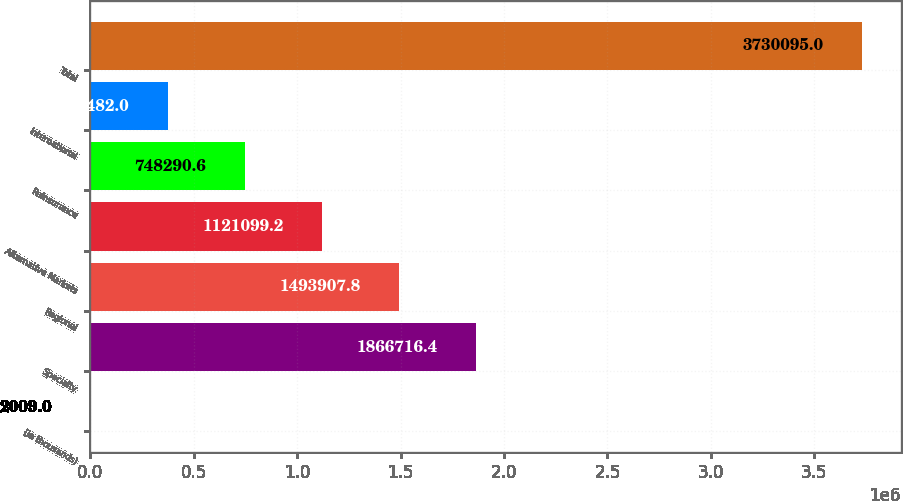Convert chart to OTSL. <chart><loc_0><loc_0><loc_500><loc_500><bar_chart><fcel>(In thousands)<fcel>Specialty<fcel>Regional<fcel>Alternative Markets<fcel>Reinsurance<fcel>International<fcel>Total<nl><fcel>2009<fcel>1.86672e+06<fcel>1.49391e+06<fcel>1.1211e+06<fcel>748291<fcel>375482<fcel>3.7301e+06<nl></chart> 